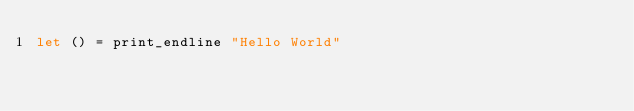Convert code to text. <code><loc_0><loc_0><loc_500><loc_500><_OCaml_>let () = print_endline "Hello World"
</code> 